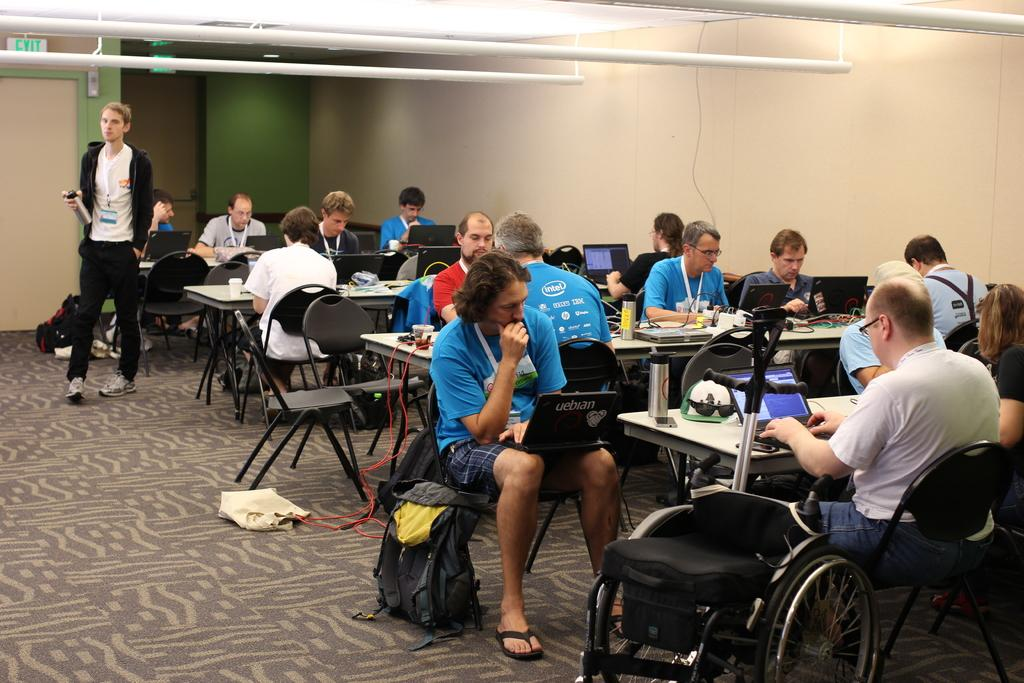What are the people in the image doing? The people in the image are sitting on chairs and working with laptops. Can you describe the man in the image? There is a man walking in the image. What is the purpose of the door in the image? The door in the image may provide access to another room or area. What is the exit board used for in the image? The exit board in the image may provide information or instructions related to exiting the area. What color is the sweater worn by the man in the image? There is no mention of a sweater in the image, so we cannot determine its color. 